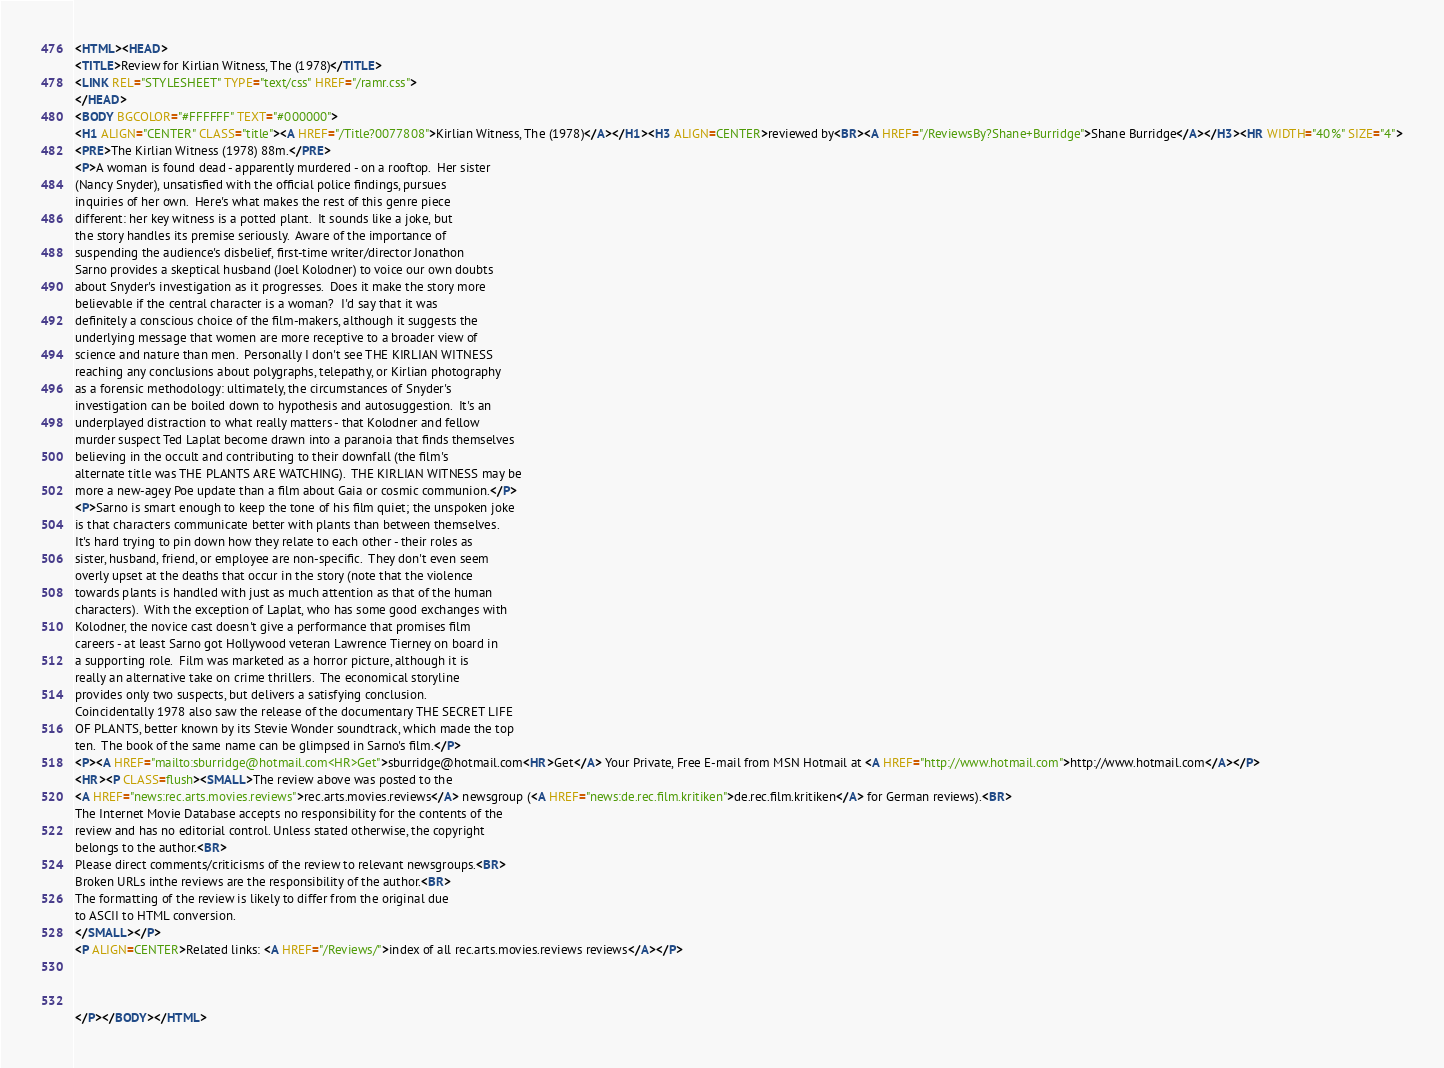Convert code to text. <code><loc_0><loc_0><loc_500><loc_500><_HTML_><HTML><HEAD>
<TITLE>Review for Kirlian Witness, The (1978)</TITLE>
<LINK REL="STYLESHEET" TYPE="text/css" HREF="/ramr.css">
</HEAD>
<BODY BGCOLOR="#FFFFFF" TEXT="#000000">
<H1 ALIGN="CENTER" CLASS="title"><A HREF="/Title?0077808">Kirlian Witness, The (1978)</A></H1><H3 ALIGN=CENTER>reviewed by<BR><A HREF="/ReviewsBy?Shane+Burridge">Shane Burridge</A></H3><HR WIDTH="40%" SIZE="4">
<PRE>The Kirlian Witness (1978) 88m.</PRE>
<P>A woman is found dead - apparently murdered - on a rooftop.  Her sister 
(Nancy Snyder), unsatisfied with the official police findings, pursues 
inquiries of her own.  Here's what makes the rest of this genre piece 
different: her key witness is a potted plant.  It sounds like a joke, but 
the story handles its premise seriously.  Aware of the importance of 
suspending the audience's disbelief, first-time writer/director Jonathon 
Sarno provides a skeptical husband (Joel Kolodner) to voice our own doubts 
about Snyder's investigation as it progresses.  Does it make the story more 
believable if the central character is a woman?  I'd say that it was 
definitely a conscious choice of the film-makers, although it suggests the 
underlying message that women are more receptive to a broader view of 
science and nature than men.  Personally I don't see THE KIRLIAN WITNESS 
reaching any conclusions about polygraphs, telepathy, or Kirlian photography 
as a forensic methodology: ultimately, the circumstances of Snyder's 
investigation can be boiled down to hypothesis and autosuggestion.  It's an 
underplayed distraction to what really matters - that Kolodner and fellow 
murder suspect Ted Laplat become drawn into a paranoia that finds themselves 
believing in the occult and contributing to their downfall (the film's 
alternate title was THE PLANTS ARE WATCHING).  THE KIRLIAN WITNESS may be 
more a new-agey Poe update than a film about Gaia or cosmic communion.</P>
<P>Sarno is smart enough to keep the tone of his film quiet; the unspoken joke 
is that characters communicate better with plants than between themselves.  
It's hard trying to pin down how they relate to each other - their roles as 
sister, husband, friend, or employee are non-specific.  They don't even seem 
overly upset at the deaths that occur in the story (note that the violence 
towards plants is handled with just as much attention as that of the human 
characters).  With the exception of Laplat, who has some good exchanges with 
Kolodner, the novice cast doesn't give a performance that promises film 
careers - at least Sarno got Hollywood veteran Lawrence Tierney on board in 
a supporting role.  Film was marketed as a horror picture, although it is 
really an alternative take on crime thrillers.  The economical storyline 
provides only two suspects, but delivers a satisfying conclusion.  
Coincidentally 1978 also saw the release of the documentary THE SECRET LIFE 
OF PLANTS, better known by its Stevie Wonder soundtrack, which made the top 
ten.  The book of the same name can be glimpsed in Sarno's film.</P>
<P><A HREF="mailto:sburridge@hotmail.com<HR>Get">sburridge@hotmail.com<HR>Get</A> Your Private, Free E-mail from MSN Hotmail at <A HREF="http://www.hotmail.com">http://www.hotmail.com</A></P>
<HR><P CLASS=flush><SMALL>The review above was posted to the
<A HREF="news:rec.arts.movies.reviews">rec.arts.movies.reviews</A> newsgroup (<A HREF="news:de.rec.film.kritiken">de.rec.film.kritiken</A> for German reviews).<BR>
The Internet Movie Database accepts no responsibility for the contents of the
review and has no editorial control. Unless stated otherwise, the copyright
belongs to the author.<BR>
Please direct comments/criticisms of the review to relevant newsgroups.<BR>
Broken URLs inthe reviews are the responsibility of the author.<BR>
The formatting of the review is likely to differ from the original due
to ASCII to HTML conversion.
</SMALL></P>
<P ALIGN=CENTER>Related links: <A HREF="/Reviews/">index of all rec.arts.movies.reviews reviews</A></P>



</P></BODY></HTML>
</code> 